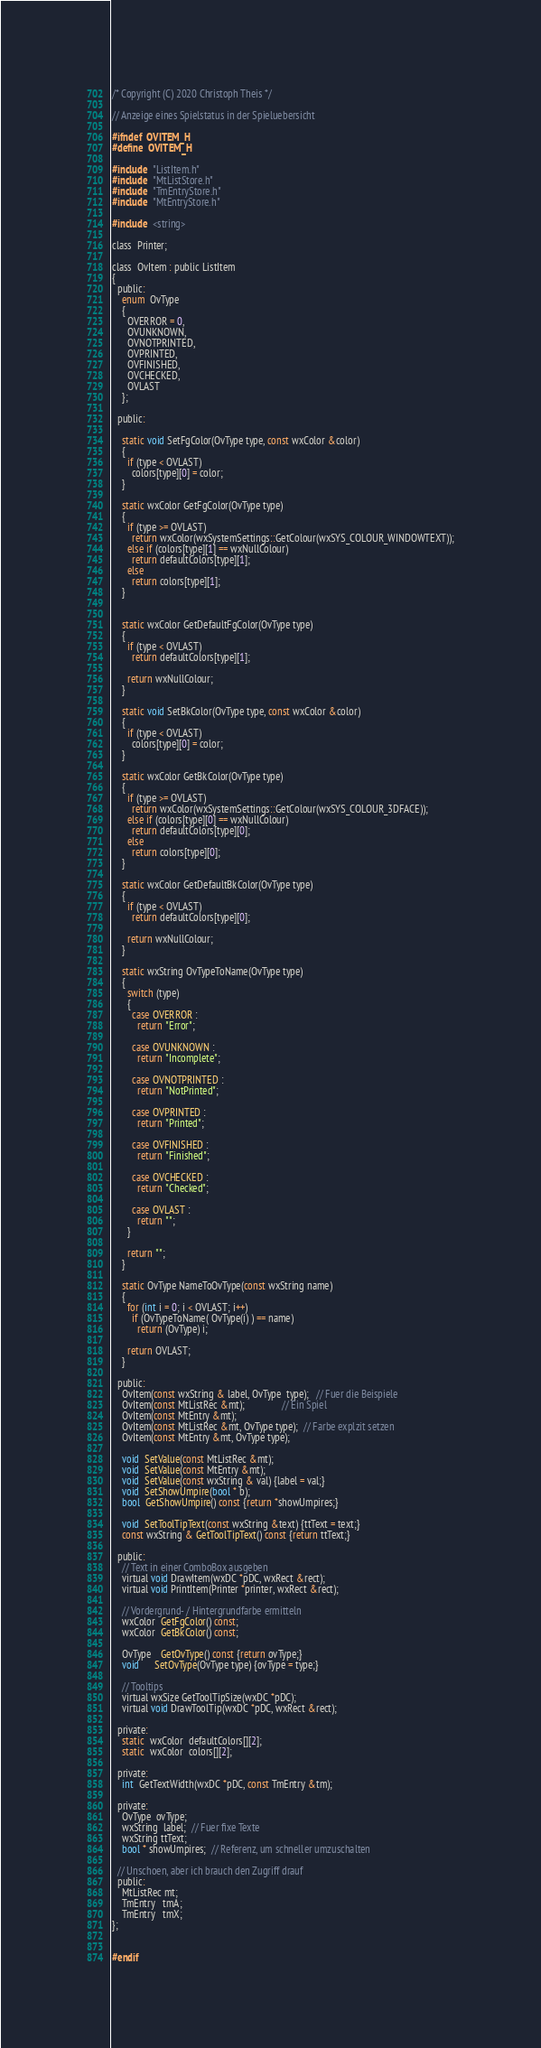Convert code to text. <code><loc_0><loc_0><loc_500><loc_500><_C_>/* Copyright (C) 2020 Christoph Theis */

// Anzeige eines Spielstatus in der Spieluebersicht

#ifndef  OVITEM_H
#define  OVITEM_H

#include  "ListItem.h"
#include  "MtListStore.h"
#include  "TmEntryStore.h"
#include  "MtEntryStore.h"

#include  <string>

class  Printer;

class  OvItem : public ListItem
{
  public:
    enum  OvType
    {
      OVERROR = 0,
      OVUNKNOWN,
      OVNOTPRINTED,
      OVPRINTED,
      OVFINISHED,
      OVCHECKED,
      OVLAST
    };
    
  public:
  
    static void SetFgColor(OvType type, const wxColor &color) 
    {
      if (type < OVLAST)
        colors[type][0] = color;
    }

    static wxColor GetFgColor(OvType type)
    {
      if (type >= OVLAST)        
        return wxColor(wxSystemSettings::GetColour(wxSYS_COLOUR_WINDOWTEXT));
      else if (colors[type][1] == wxNullColour)
        return defaultColors[type][1];
      else
        return colors[type][1];
    }


    static wxColor GetDefaultFgColor(OvType type) 
    {
      if (type < OVLAST)
        return defaultColors[type][1];

      return wxNullColour;
    }

    static void SetBkColor(OvType type, const wxColor &color)
    {
      if (type < OVLAST)
        colors[type][0] = color;
    }
    
    static wxColor GetBkColor(OvType type)
    {
      if (type >= OVLAST)
        return wxColor(wxSystemSettings::GetColour(wxSYS_COLOUR_3DFACE));
      else if (colors[type][0] == wxNullColour)
        return defaultColors[type][0];
      else
        return colors[type][0];
    }

    static wxColor GetDefaultBkColor(OvType type)
    {
      if (type < OVLAST)
        return defaultColors[type][0];

      return wxNullColour;
    }

    static wxString OvTypeToName(OvType type)
    {
      switch (type)
      {
        case OVERROR : 
          return "Error";

        case OVUNKNOWN :
          return "Incomplete";

        case OVNOTPRINTED :
          return "NotPrinted";

        case OVPRINTED :
          return "Printed";

        case OVFINISHED :
          return "Finished";

        case OVCHECKED :
          return "Checked";

        case OVLAST :
          return "";
      }

      return "";
    }

    static OvType NameToOvType(const wxString name)
    {
      for (int i = 0; i < OVLAST; i++)
        if (OvTypeToName( OvType(i) ) == name)
          return (OvType) i;

      return OVLAST;
    }

  public:
    OvItem(const wxString & label, OvType  type);   // Fuer die Beispiele
    OvItem(const MtListRec &mt);               // Ein Spiel
    OvItem(const MtEntry &mt);
    OvItem(const MtListRec &mt, OvType type);  // Farbe explzit setzen
    OvItem(const MtEntry &mt, OvType type);

    void  SetValue(const MtListRec &mt);
    void  SetValue(const MtEntry &mt);
    void  SetValue(const wxString & val) {label = val;}
    void  SetShowUmpire(bool * b);
    bool  GetShowUmpire() const {return *showUmpires;}

    void  SetToolTipText(const wxString &text) {ttText = text;}
    const wxString & GetToolTipText() const {return ttText;}

  public:
    // Text in einer ComboBox ausgeben
    virtual void DrawItem(wxDC *pDC, wxRect &rect);
    virtual void PrintItem(Printer *printer, wxRect &rect);

    // Vordergrund- / Hintergrundfarbe ermitteln
    wxColor  GetFgColor() const;
    wxColor  GetBkColor() const;
    
    OvType    GetOvType() const {return ovType;}
    void      SetOvType(OvType type) {ovType = type;}

    // Tooltips
    virtual wxSize GetToolTipSize(wxDC *pDC);
    virtual void DrawToolTip(wxDC *pDC, wxRect &rect);

  private:
    static  wxColor  defaultColors[][2];
    static  wxColor  colors[][2];

  private:
    int  GetTextWidth(wxDC *pDC, const TmEntry &tm);

  private:
    OvType  ovType;
    wxString  label;  // Fuer fixe Texte
    wxString ttText;
    bool * showUmpires;  // Referenz, um schneller umzuschalten

  // Unschoen, aber ich brauch den Zugriff drauf
  public:
    MtListRec mt;
    TmEntry   tmA;
    TmEntry   tmX;
};


#endif</code> 